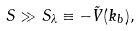<formula> <loc_0><loc_0><loc_500><loc_500>S \gg S _ { \lambda } \equiv - \tilde { V } ( k _ { b } ) ,</formula> 